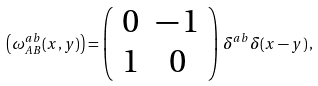Convert formula to latex. <formula><loc_0><loc_0><loc_500><loc_500>\left ( \omega _ { A B } ^ { a b } ( x , y ) \right ) = \left ( \begin{array} { c c } 0 & - \, 1 \\ 1 & 0 \end{array} \right ) \, \delta ^ { a b } \delta ( x - y ) \, ,</formula> 